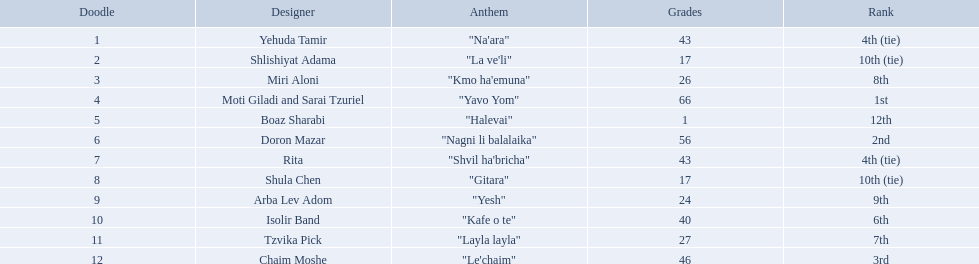What is the place of the contestant who received only 1 point? 12th. What is the name of the artist listed in the previous question? Boaz Sharabi. 